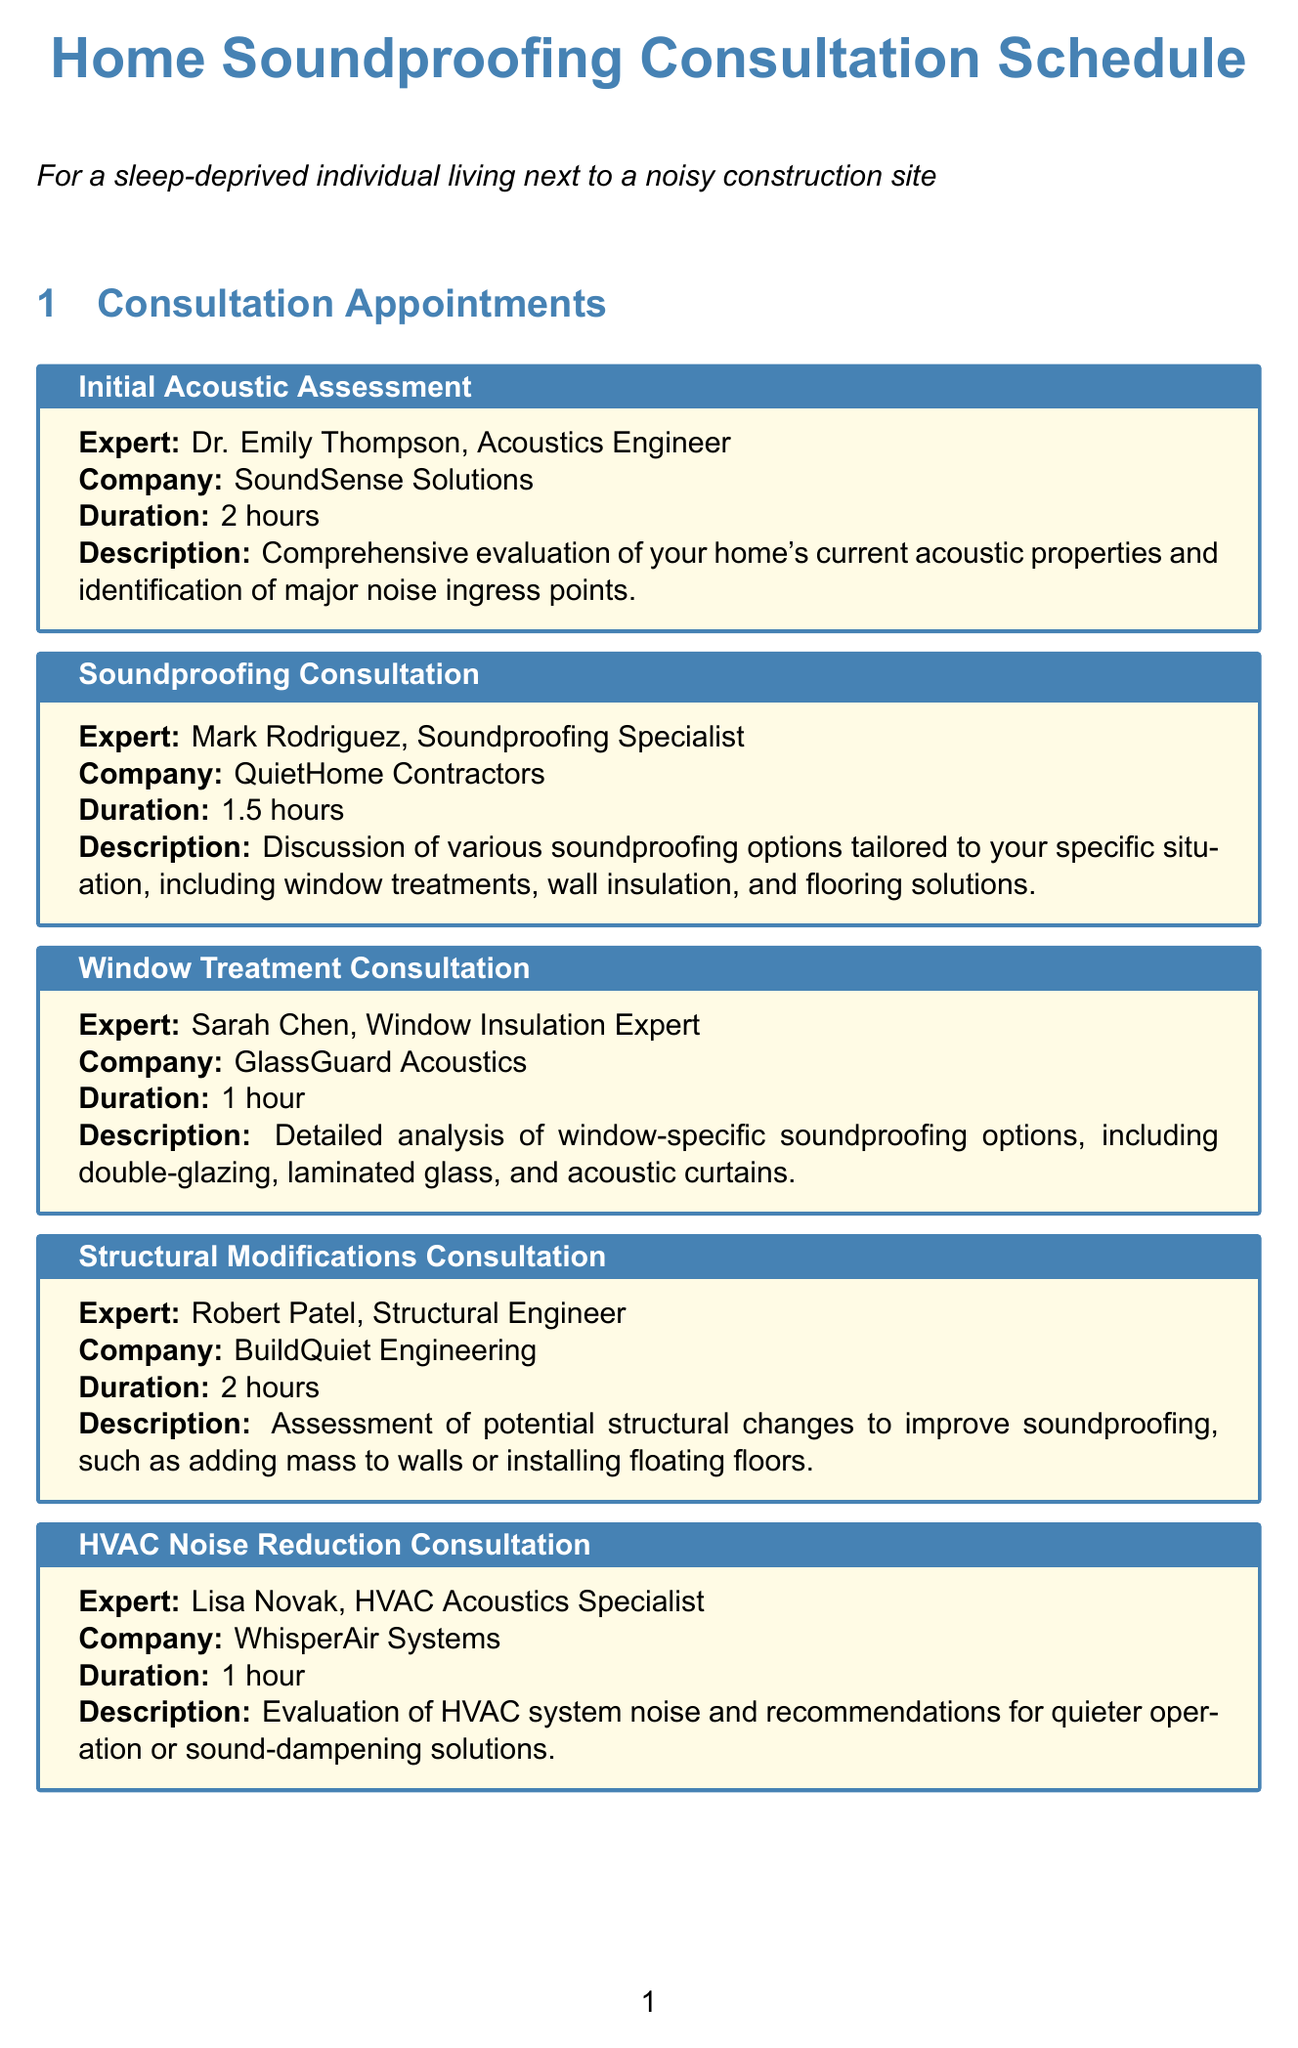what is the duration of the Initial Acoustic Assessment? The duration is specifically mentioned in the consultation details for the Initial Acoustic Assessment.
Answer: 2 hours who is the expert for the Soundproofing Consultation? The document lists Mark Rodriguez as the expert for that specific consultation.
Answer: Mark Rodriguez what materials are needed for the Window Treatment Consultation? The document details that specific materials are required for each consultation, including window measurements and current window specifications for this one.
Answer: Window measurements, Current window specifications how long is the Final Project Planning consultation expected to last? The duration is explicitly stated in the document as part of the Final Project Planning consultation details.
Answer: 3 hours which company does Lisa Novak represent? Lisa Novak's consulting appointment is associated with a specific company mentioned in the document.
Answer: WhisperAir Systems what is the main focus of the Legal Consultation? The description in the document specifies the key topics addressed in this particular consultation.
Answer: Legal rights and potential actions regarding construction noise how many consultations involve a duration of 2 hours? By counting the specific durations listed in the document, we can determine how many consultations are scheduled for that length.
Answer: 2 consultations what must be prepared for the Structural Modifications Consultation? The document outlines what materials need to be ready for each consultation, including home structural plans and building code regulations for this consultation.
Answer: Home structural plans, Building code regulations 